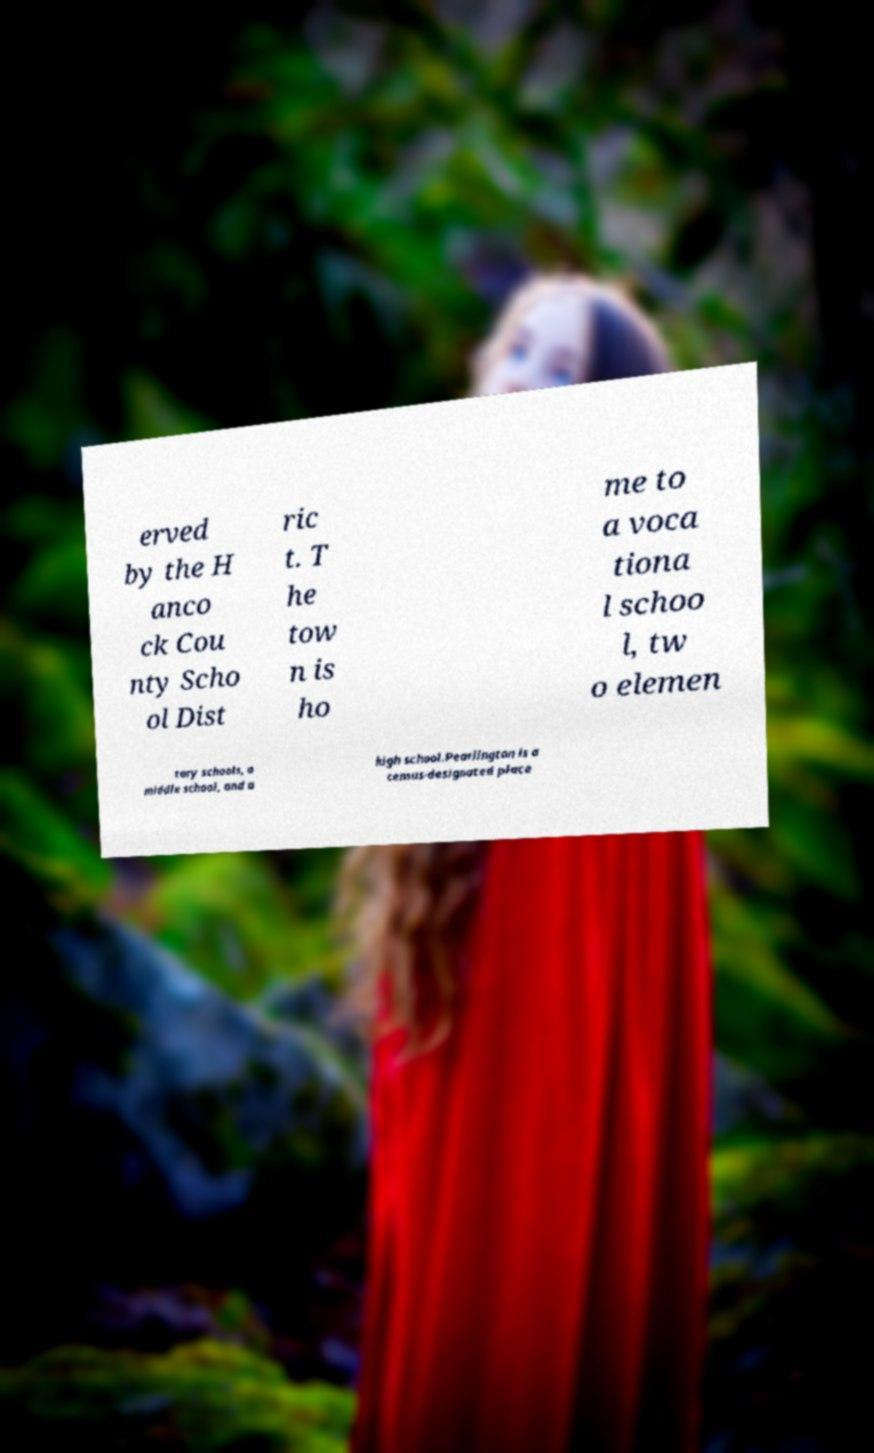Please read and relay the text visible in this image. What does it say? erved by the H anco ck Cou nty Scho ol Dist ric t. T he tow n is ho me to a voca tiona l schoo l, tw o elemen tary schools, a middle school, and a high school.Pearlington is a census-designated place 